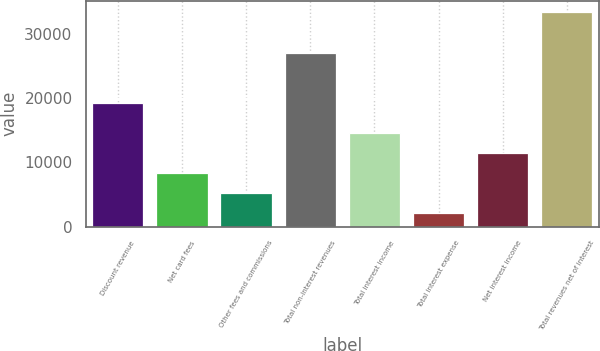Convert chart. <chart><loc_0><loc_0><loc_500><loc_500><bar_chart><fcel>Discount revenue<fcel>Net card fees<fcel>Other fees and commissions<fcel>Total non-interest revenues<fcel>Total interest income<fcel>Total interest expense<fcel>Net interest income<fcel>Total revenues net of interest<nl><fcel>19186<fcel>8383.8<fcel>5247.9<fcel>27030<fcel>14655.6<fcel>2112<fcel>11519.7<fcel>33471<nl></chart> 